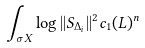<formula> <loc_0><loc_0><loc_500><loc_500>\int _ { \sigma X } \log | | S _ { \Delta _ { i } } | | ^ { 2 } c _ { 1 } ( L ) ^ { n }</formula> 